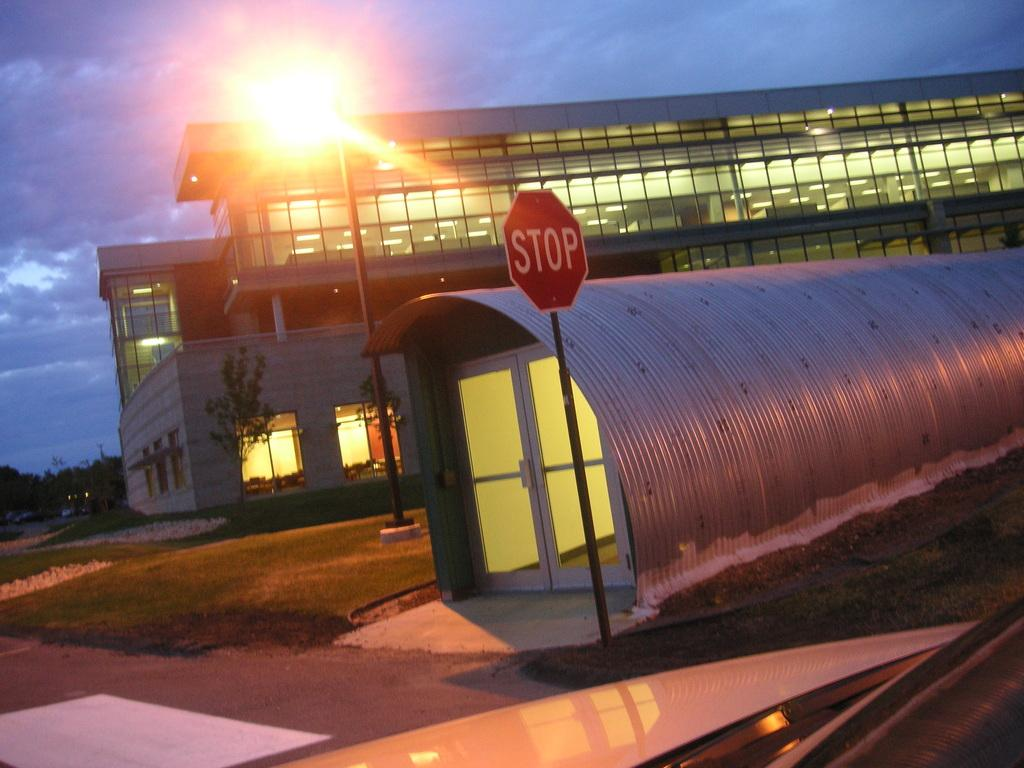Provide a one-sentence caption for the provided image. Red stop sign outside of a small building. 